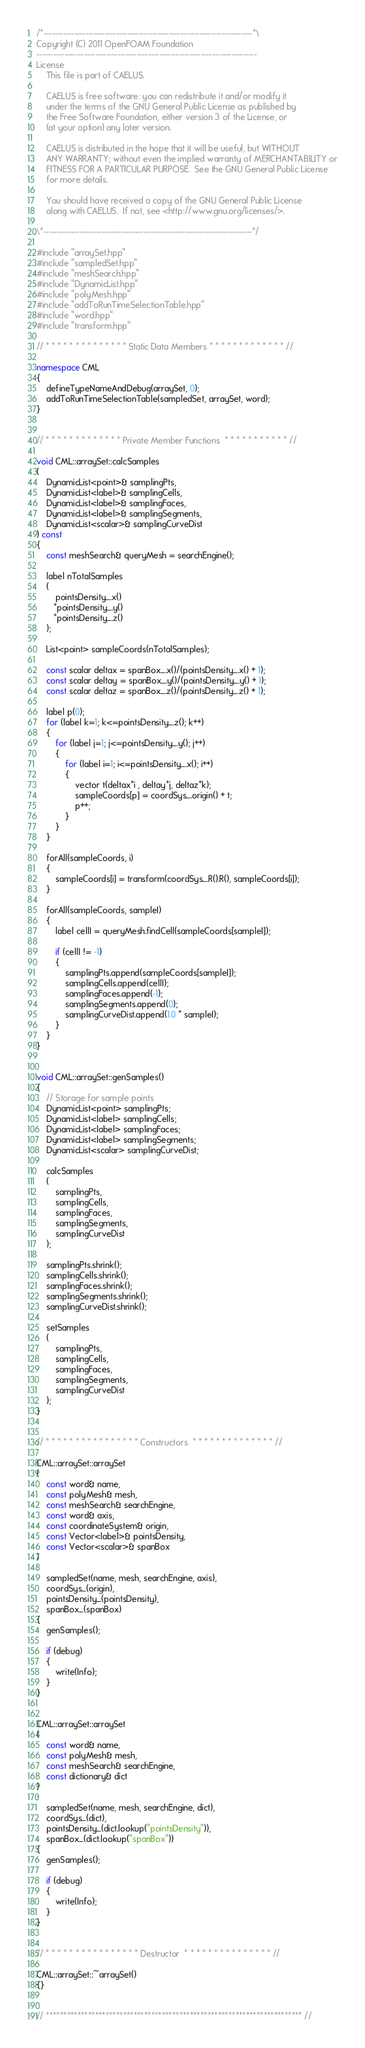<code> <loc_0><loc_0><loc_500><loc_500><_C++_>/*---------------------------------------------------------------------------*\
Copyright (C) 2011 OpenFOAM Foundation
-------------------------------------------------------------------------------
License
    This file is part of CAELUS.

    CAELUS is free software: you can redistribute it and/or modify it
    under the terms of the GNU General Public License as published by
    the Free Software Foundation, either version 3 of the License, or
    (at your option) any later version.

    CAELUS is distributed in the hope that it will be useful, but WITHOUT
    ANY WARRANTY; without even the implied warranty of MERCHANTABILITY or
    FITNESS FOR A PARTICULAR PURPOSE.  See the GNU General Public License
    for more details.

    You should have received a copy of the GNU General Public License
    along with CAELUS.  If not, see <http://www.gnu.org/licenses/>.

\*---------------------------------------------------------------------------*/

#include "arraySet.hpp"
#include "sampledSet.hpp"
#include "meshSearch.hpp"
#include "DynamicList.hpp"
#include "polyMesh.hpp"
#include "addToRunTimeSelectionTable.hpp"
#include "word.hpp"
#include "transform.hpp"

// * * * * * * * * * * * * * * Static Data Members * * * * * * * * * * * * * //

namespace CML
{
    defineTypeNameAndDebug(arraySet, 0);
    addToRunTimeSelectionTable(sampledSet, arraySet, word);
}


// * * * * * * * * * * * * * Private Member Functions  * * * * * * * * * * * //

void CML::arraySet::calcSamples
(
    DynamicList<point>& samplingPts,
    DynamicList<label>& samplingCells,
    DynamicList<label>& samplingFaces,
    DynamicList<label>& samplingSegments,
    DynamicList<scalar>& samplingCurveDist
) const
{
    const meshSearch& queryMesh = searchEngine();

    label nTotalSamples
    (
        pointsDensity_.x()
       *pointsDensity_.y()
       *pointsDensity_.z()
    );

    List<point> sampleCoords(nTotalSamples);

    const scalar deltax = spanBox_.x()/(pointsDensity_.x() + 1);
    const scalar deltay = spanBox_.y()/(pointsDensity_.y() + 1);
    const scalar deltaz = spanBox_.z()/(pointsDensity_.z() + 1);

    label p(0);
    for (label k=1; k<=pointsDensity_.z(); k++)
    {
        for (label j=1; j<=pointsDensity_.y(); j++)
        {
            for (label i=1; i<=pointsDensity_.x(); i++)
            {
                vector t(deltax*i , deltay*j, deltaz*k);
                sampleCoords[p] = coordSys_.origin() + t;
                p++;
            }
        }
    }

    forAll(sampleCoords, i)
    {
        sampleCoords[i] = transform(coordSys_.R().R(), sampleCoords[i]);
    }

    forAll(sampleCoords, sampleI)
    {
        label cellI = queryMesh.findCell(sampleCoords[sampleI]);

        if (cellI != -1)
        {
            samplingPts.append(sampleCoords[sampleI]);
            samplingCells.append(cellI);
            samplingFaces.append(-1);
            samplingSegments.append(0);
            samplingCurveDist.append(1.0 * sampleI);
        }
    }
}


void CML::arraySet::genSamples()
{
    // Storage for sample points
    DynamicList<point> samplingPts;
    DynamicList<label> samplingCells;
    DynamicList<label> samplingFaces;
    DynamicList<label> samplingSegments;
    DynamicList<scalar> samplingCurveDist;

    calcSamples
    (
        samplingPts,
        samplingCells,
        samplingFaces,
        samplingSegments,
        samplingCurveDist
    );

    samplingPts.shrink();
    samplingCells.shrink();
    samplingFaces.shrink();
    samplingSegments.shrink();
    samplingCurveDist.shrink();

    setSamples
    (
        samplingPts,
        samplingCells,
        samplingFaces,
        samplingSegments,
        samplingCurveDist
    );
}


// * * * * * * * * * * * * * * * * Constructors  * * * * * * * * * * * * * * //

CML::arraySet::arraySet
(
    const word& name,
    const polyMesh& mesh,
    const meshSearch& searchEngine,
    const word& axis,
    const coordinateSystem& origin,
    const Vector<label>& pointsDensity,
    const Vector<scalar>& spanBox
)
:
    sampledSet(name, mesh, searchEngine, axis),
    coordSys_(origin),
    pointsDensity_(pointsDensity),
    spanBox_(spanBox)
{
    genSamples();

    if (debug)
    {
        write(Info);
    }
}


CML::arraySet::arraySet
(
    const word& name,
    const polyMesh& mesh,
    const meshSearch& searchEngine,
    const dictionary& dict
)
:
    sampledSet(name, mesh, searchEngine, dict),
    coordSys_(dict),
    pointsDensity_(dict.lookup("pointsDensity")),
    spanBox_(dict.lookup("spanBox"))
{
    genSamples();

    if (debug)
    {
        write(Info);
    }
}


// * * * * * * * * * * * * * * * * Destructor  * * * * * * * * * * * * * * * //

CML::arraySet::~arraySet()
{}


// ************************************************************************* //
</code> 